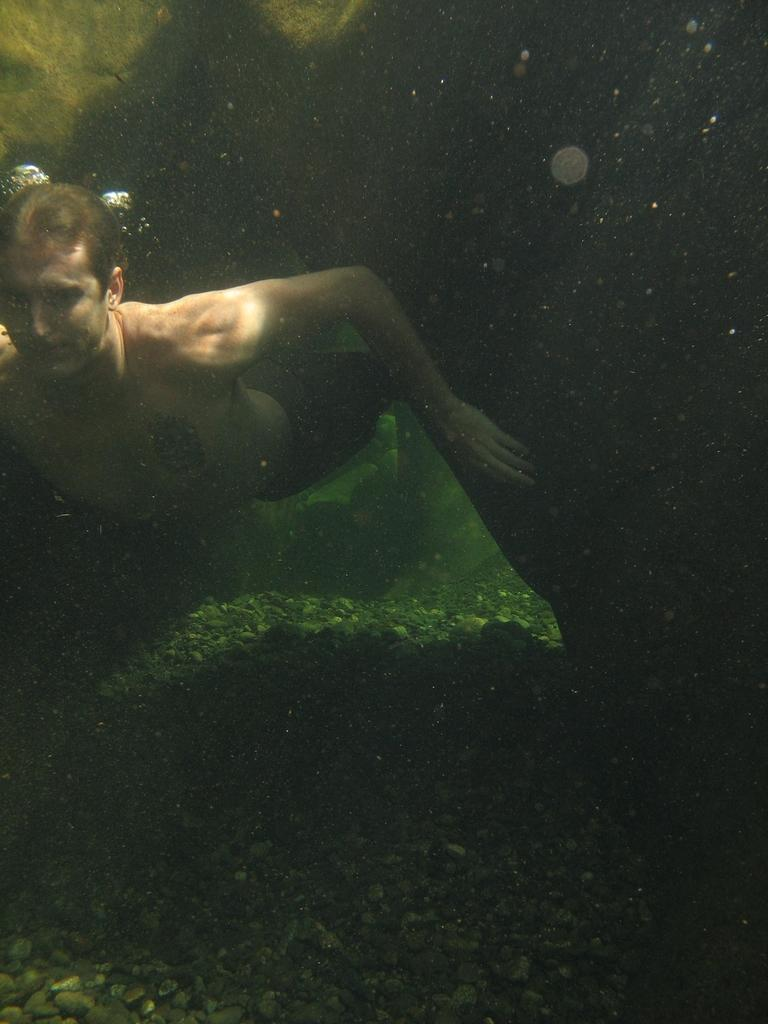What is the man in the image doing? The man is swimming in the image. Can you describe the specific type of swimming being depicted? The man is swimming underwater in the image. What can be seen on the ground in the image? Aquatic plants are present on the ground in the image. What story is the man telling while swimming in the image? There is no indication in the image that the man is telling a story while swimming. 